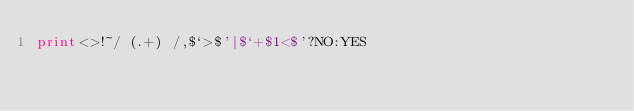Convert code to text. <code><loc_0><loc_0><loc_500><loc_500><_Perl_>print<>!~/ (.+) /,$`>$'|$`+$1<$'?NO:YES</code> 